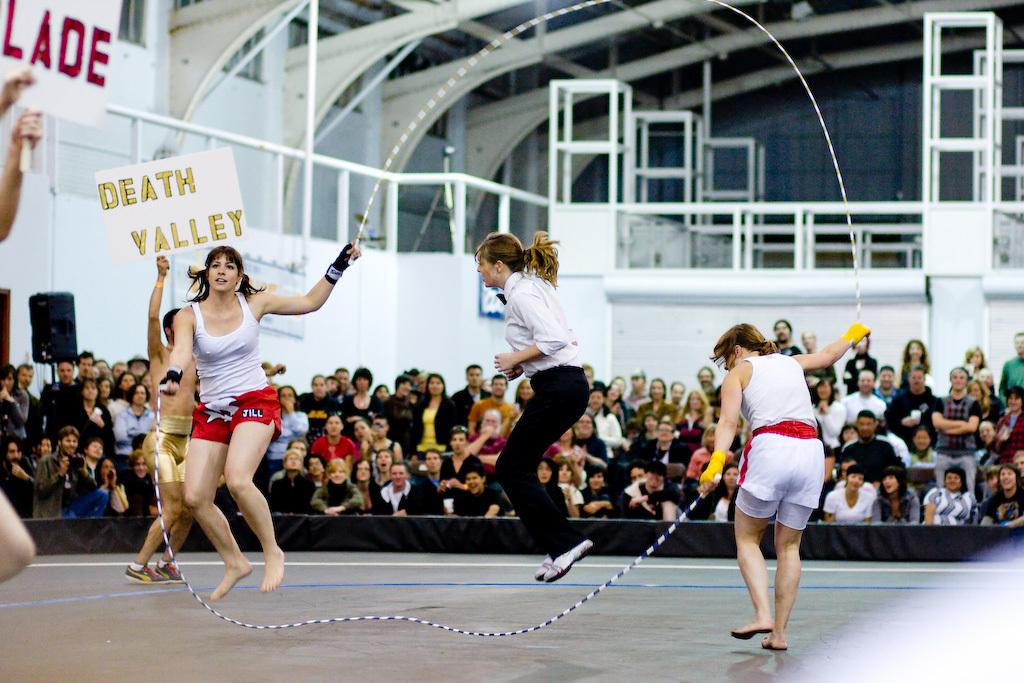How many people are in the image? There is a group of people in the image. What are some of the people holding in the image? Some people are holding name boards in the image. What can be seen in the background of the image? There are rods and a roof visible in the background of the image. Can you tell me which aunt is leading the group in the image? There is no aunt mentioned or visible in the image. Is there a tiger present in the image? No, there is no tiger present in the image. 